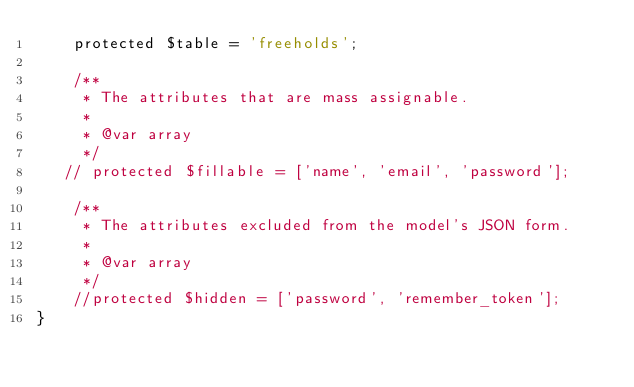Convert code to text. <code><loc_0><loc_0><loc_500><loc_500><_PHP_>    protected $table = 'freeholds';

    /**
     * The attributes that are mass assignable.
     *
     * @var array
     */
   // protected $fillable = ['name', 'email', 'password'];

    /**
     * The attributes excluded from the model's JSON form.
     *
     * @var array
     */
    //protected $hidden = ['password', 'remember_token'];
}
</code> 